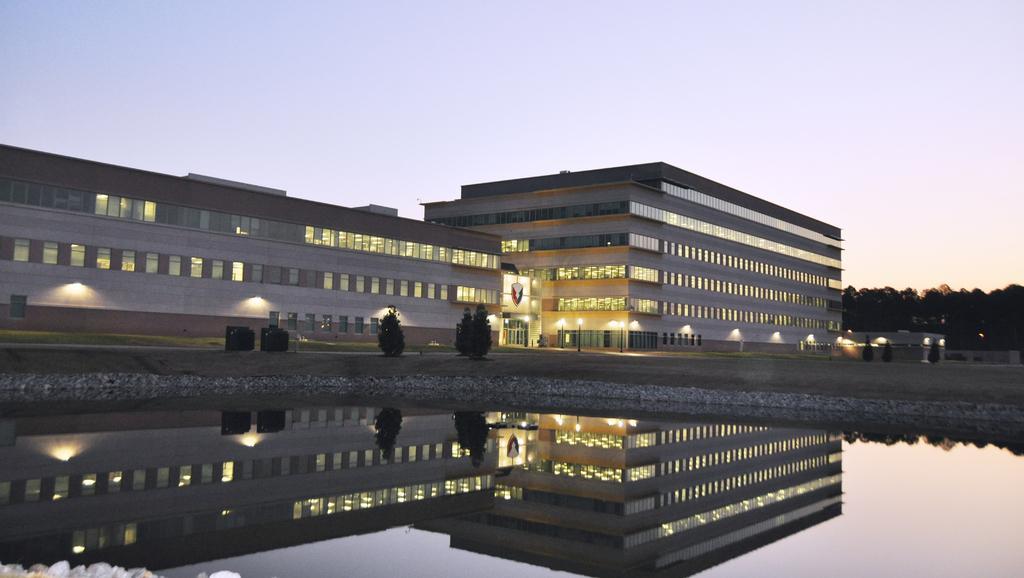In one or two sentences, can you explain what this image depicts? In the picture I can see the water, trees, building, lights and the plain sky in the background. 